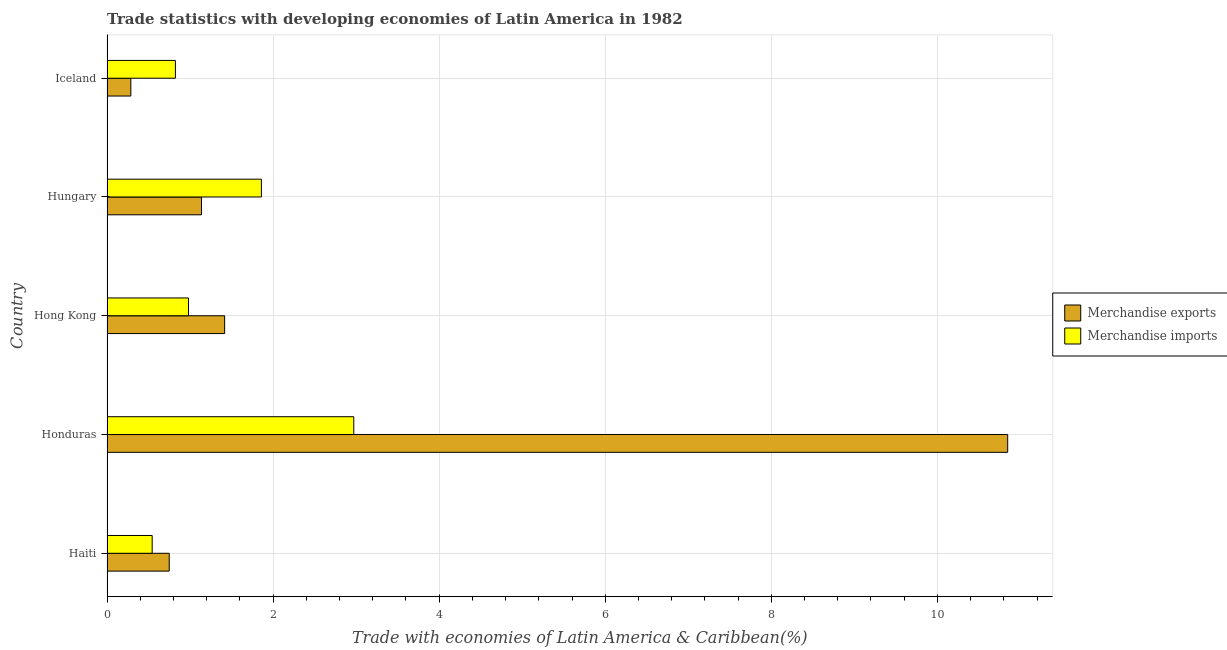How many groups of bars are there?
Ensure brevity in your answer.  5. Are the number of bars on each tick of the Y-axis equal?
Provide a short and direct response. Yes. How many bars are there on the 2nd tick from the top?
Ensure brevity in your answer.  2. How many bars are there on the 4th tick from the bottom?
Provide a succinct answer. 2. What is the label of the 3rd group of bars from the top?
Offer a terse response. Hong Kong. What is the merchandise exports in Hong Kong?
Give a very brief answer. 1.42. Across all countries, what is the maximum merchandise imports?
Your answer should be compact. 2.97. Across all countries, what is the minimum merchandise exports?
Your answer should be compact. 0.29. In which country was the merchandise imports maximum?
Give a very brief answer. Honduras. In which country was the merchandise imports minimum?
Offer a very short reply. Haiti. What is the total merchandise imports in the graph?
Your answer should be compact. 7.18. What is the difference between the merchandise imports in Haiti and that in Honduras?
Offer a terse response. -2.43. What is the difference between the merchandise imports in Hungary and the merchandise exports in Haiti?
Your response must be concise. 1.11. What is the average merchandise exports per country?
Keep it short and to the point. 2.89. What is the difference between the merchandise exports and merchandise imports in Haiti?
Your answer should be very brief. 0.2. In how many countries, is the merchandise imports greater than 0.4 %?
Keep it short and to the point. 5. What is the ratio of the merchandise exports in Hungary to that in Iceland?
Provide a short and direct response. 3.96. What is the difference between the highest and the second highest merchandise imports?
Your response must be concise. 1.11. What is the difference between the highest and the lowest merchandise imports?
Your answer should be very brief. 2.43. Is the sum of the merchandise imports in Hungary and Iceland greater than the maximum merchandise exports across all countries?
Make the answer very short. No. What does the 2nd bar from the top in Iceland represents?
Your answer should be very brief. Merchandise exports. Are all the bars in the graph horizontal?
Your answer should be very brief. Yes. How many countries are there in the graph?
Provide a short and direct response. 5. What is the difference between two consecutive major ticks on the X-axis?
Your answer should be compact. 2. Does the graph contain any zero values?
Offer a terse response. No. Does the graph contain grids?
Ensure brevity in your answer.  Yes. Where does the legend appear in the graph?
Your response must be concise. Center right. How are the legend labels stacked?
Give a very brief answer. Vertical. What is the title of the graph?
Provide a short and direct response. Trade statistics with developing economies of Latin America in 1982. Does "Lowest 20% of population" appear as one of the legend labels in the graph?
Ensure brevity in your answer.  No. What is the label or title of the X-axis?
Give a very brief answer. Trade with economies of Latin America & Caribbean(%). What is the label or title of the Y-axis?
Offer a terse response. Country. What is the Trade with economies of Latin America & Caribbean(%) of Merchandise exports in Haiti?
Provide a short and direct response. 0.75. What is the Trade with economies of Latin America & Caribbean(%) in Merchandise imports in Haiti?
Your response must be concise. 0.54. What is the Trade with economies of Latin America & Caribbean(%) of Merchandise exports in Honduras?
Keep it short and to the point. 10.85. What is the Trade with economies of Latin America & Caribbean(%) of Merchandise imports in Honduras?
Your answer should be compact. 2.97. What is the Trade with economies of Latin America & Caribbean(%) of Merchandise exports in Hong Kong?
Keep it short and to the point. 1.42. What is the Trade with economies of Latin America & Caribbean(%) of Merchandise imports in Hong Kong?
Ensure brevity in your answer.  0.98. What is the Trade with economies of Latin America & Caribbean(%) of Merchandise exports in Hungary?
Give a very brief answer. 1.14. What is the Trade with economies of Latin America & Caribbean(%) in Merchandise imports in Hungary?
Provide a short and direct response. 1.86. What is the Trade with economies of Latin America & Caribbean(%) of Merchandise exports in Iceland?
Offer a very short reply. 0.29. What is the Trade with economies of Latin America & Caribbean(%) of Merchandise imports in Iceland?
Keep it short and to the point. 0.82. Across all countries, what is the maximum Trade with economies of Latin America & Caribbean(%) of Merchandise exports?
Offer a very short reply. 10.85. Across all countries, what is the maximum Trade with economies of Latin America & Caribbean(%) of Merchandise imports?
Your answer should be very brief. 2.97. Across all countries, what is the minimum Trade with economies of Latin America & Caribbean(%) of Merchandise exports?
Keep it short and to the point. 0.29. Across all countries, what is the minimum Trade with economies of Latin America & Caribbean(%) of Merchandise imports?
Ensure brevity in your answer.  0.54. What is the total Trade with economies of Latin America & Caribbean(%) of Merchandise exports in the graph?
Your response must be concise. 14.44. What is the total Trade with economies of Latin America & Caribbean(%) in Merchandise imports in the graph?
Ensure brevity in your answer.  7.18. What is the difference between the Trade with economies of Latin America & Caribbean(%) of Merchandise exports in Haiti and that in Honduras?
Your answer should be compact. -10.1. What is the difference between the Trade with economies of Latin America & Caribbean(%) of Merchandise imports in Haiti and that in Honduras?
Offer a terse response. -2.43. What is the difference between the Trade with economies of Latin America & Caribbean(%) in Merchandise exports in Haiti and that in Hong Kong?
Keep it short and to the point. -0.67. What is the difference between the Trade with economies of Latin America & Caribbean(%) of Merchandise imports in Haiti and that in Hong Kong?
Offer a very short reply. -0.44. What is the difference between the Trade with economies of Latin America & Caribbean(%) of Merchandise exports in Haiti and that in Hungary?
Offer a terse response. -0.39. What is the difference between the Trade with economies of Latin America & Caribbean(%) of Merchandise imports in Haiti and that in Hungary?
Your answer should be very brief. -1.32. What is the difference between the Trade with economies of Latin America & Caribbean(%) of Merchandise exports in Haiti and that in Iceland?
Provide a short and direct response. 0.46. What is the difference between the Trade with economies of Latin America & Caribbean(%) of Merchandise imports in Haiti and that in Iceland?
Your answer should be compact. -0.28. What is the difference between the Trade with economies of Latin America & Caribbean(%) in Merchandise exports in Honduras and that in Hong Kong?
Your answer should be compact. 9.43. What is the difference between the Trade with economies of Latin America & Caribbean(%) in Merchandise imports in Honduras and that in Hong Kong?
Your answer should be compact. 1.99. What is the difference between the Trade with economies of Latin America & Caribbean(%) of Merchandise exports in Honduras and that in Hungary?
Provide a short and direct response. 9.71. What is the difference between the Trade with economies of Latin America & Caribbean(%) of Merchandise imports in Honduras and that in Hungary?
Keep it short and to the point. 1.11. What is the difference between the Trade with economies of Latin America & Caribbean(%) of Merchandise exports in Honduras and that in Iceland?
Ensure brevity in your answer.  10.56. What is the difference between the Trade with economies of Latin America & Caribbean(%) in Merchandise imports in Honduras and that in Iceland?
Offer a terse response. 2.15. What is the difference between the Trade with economies of Latin America & Caribbean(%) in Merchandise exports in Hong Kong and that in Hungary?
Keep it short and to the point. 0.28. What is the difference between the Trade with economies of Latin America & Caribbean(%) of Merchandise imports in Hong Kong and that in Hungary?
Offer a very short reply. -0.88. What is the difference between the Trade with economies of Latin America & Caribbean(%) in Merchandise exports in Hong Kong and that in Iceland?
Your answer should be compact. 1.13. What is the difference between the Trade with economies of Latin America & Caribbean(%) in Merchandise imports in Hong Kong and that in Iceland?
Ensure brevity in your answer.  0.16. What is the difference between the Trade with economies of Latin America & Caribbean(%) in Merchandise exports in Hungary and that in Iceland?
Offer a terse response. 0.85. What is the difference between the Trade with economies of Latin America & Caribbean(%) of Merchandise imports in Hungary and that in Iceland?
Make the answer very short. 1.04. What is the difference between the Trade with economies of Latin America & Caribbean(%) in Merchandise exports in Haiti and the Trade with economies of Latin America & Caribbean(%) in Merchandise imports in Honduras?
Keep it short and to the point. -2.22. What is the difference between the Trade with economies of Latin America & Caribbean(%) in Merchandise exports in Haiti and the Trade with economies of Latin America & Caribbean(%) in Merchandise imports in Hong Kong?
Your answer should be compact. -0.23. What is the difference between the Trade with economies of Latin America & Caribbean(%) of Merchandise exports in Haiti and the Trade with economies of Latin America & Caribbean(%) of Merchandise imports in Hungary?
Keep it short and to the point. -1.11. What is the difference between the Trade with economies of Latin America & Caribbean(%) in Merchandise exports in Haiti and the Trade with economies of Latin America & Caribbean(%) in Merchandise imports in Iceland?
Your response must be concise. -0.07. What is the difference between the Trade with economies of Latin America & Caribbean(%) of Merchandise exports in Honduras and the Trade with economies of Latin America & Caribbean(%) of Merchandise imports in Hong Kong?
Make the answer very short. 9.87. What is the difference between the Trade with economies of Latin America & Caribbean(%) in Merchandise exports in Honduras and the Trade with economies of Latin America & Caribbean(%) in Merchandise imports in Hungary?
Offer a very short reply. 8.99. What is the difference between the Trade with economies of Latin America & Caribbean(%) in Merchandise exports in Honduras and the Trade with economies of Latin America & Caribbean(%) in Merchandise imports in Iceland?
Offer a very short reply. 10.02. What is the difference between the Trade with economies of Latin America & Caribbean(%) of Merchandise exports in Hong Kong and the Trade with economies of Latin America & Caribbean(%) of Merchandise imports in Hungary?
Provide a succinct answer. -0.44. What is the difference between the Trade with economies of Latin America & Caribbean(%) in Merchandise exports in Hong Kong and the Trade with economies of Latin America & Caribbean(%) in Merchandise imports in Iceland?
Offer a terse response. 0.59. What is the difference between the Trade with economies of Latin America & Caribbean(%) in Merchandise exports in Hungary and the Trade with economies of Latin America & Caribbean(%) in Merchandise imports in Iceland?
Keep it short and to the point. 0.31. What is the average Trade with economies of Latin America & Caribbean(%) in Merchandise exports per country?
Give a very brief answer. 2.89. What is the average Trade with economies of Latin America & Caribbean(%) of Merchandise imports per country?
Offer a terse response. 1.44. What is the difference between the Trade with economies of Latin America & Caribbean(%) of Merchandise exports and Trade with economies of Latin America & Caribbean(%) of Merchandise imports in Haiti?
Ensure brevity in your answer.  0.21. What is the difference between the Trade with economies of Latin America & Caribbean(%) in Merchandise exports and Trade with economies of Latin America & Caribbean(%) in Merchandise imports in Honduras?
Make the answer very short. 7.87. What is the difference between the Trade with economies of Latin America & Caribbean(%) in Merchandise exports and Trade with economies of Latin America & Caribbean(%) in Merchandise imports in Hong Kong?
Provide a short and direct response. 0.44. What is the difference between the Trade with economies of Latin America & Caribbean(%) of Merchandise exports and Trade with economies of Latin America & Caribbean(%) of Merchandise imports in Hungary?
Your answer should be very brief. -0.72. What is the difference between the Trade with economies of Latin America & Caribbean(%) in Merchandise exports and Trade with economies of Latin America & Caribbean(%) in Merchandise imports in Iceland?
Your answer should be very brief. -0.54. What is the ratio of the Trade with economies of Latin America & Caribbean(%) of Merchandise exports in Haiti to that in Honduras?
Provide a short and direct response. 0.07. What is the ratio of the Trade with economies of Latin America & Caribbean(%) of Merchandise imports in Haiti to that in Honduras?
Your answer should be very brief. 0.18. What is the ratio of the Trade with economies of Latin America & Caribbean(%) in Merchandise exports in Haiti to that in Hong Kong?
Provide a succinct answer. 0.53. What is the ratio of the Trade with economies of Latin America & Caribbean(%) of Merchandise imports in Haiti to that in Hong Kong?
Keep it short and to the point. 0.55. What is the ratio of the Trade with economies of Latin America & Caribbean(%) in Merchandise exports in Haiti to that in Hungary?
Ensure brevity in your answer.  0.66. What is the ratio of the Trade with economies of Latin America & Caribbean(%) of Merchandise imports in Haiti to that in Hungary?
Provide a succinct answer. 0.29. What is the ratio of the Trade with economies of Latin America & Caribbean(%) in Merchandise exports in Haiti to that in Iceland?
Your response must be concise. 2.61. What is the ratio of the Trade with economies of Latin America & Caribbean(%) in Merchandise imports in Haiti to that in Iceland?
Your answer should be compact. 0.66. What is the ratio of the Trade with economies of Latin America & Caribbean(%) of Merchandise exports in Honduras to that in Hong Kong?
Ensure brevity in your answer.  7.66. What is the ratio of the Trade with economies of Latin America & Caribbean(%) of Merchandise imports in Honduras to that in Hong Kong?
Provide a succinct answer. 3.03. What is the ratio of the Trade with economies of Latin America & Caribbean(%) of Merchandise exports in Honduras to that in Hungary?
Your response must be concise. 9.53. What is the ratio of the Trade with economies of Latin America & Caribbean(%) of Merchandise imports in Honduras to that in Hungary?
Ensure brevity in your answer.  1.6. What is the ratio of the Trade with economies of Latin America & Caribbean(%) in Merchandise exports in Honduras to that in Iceland?
Your answer should be compact. 37.78. What is the ratio of the Trade with economies of Latin America & Caribbean(%) in Merchandise imports in Honduras to that in Iceland?
Your answer should be compact. 3.61. What is the ratio of the Trade with economies of Latin America & Caribbean(%) of Merchandise exports in Hong Kong to that in Hungary?
Provide a succinct answer. 1.25. What is the ratio of the Trade with economies of Latin America & Caribbean(%) of Merchandise imports in Hong Kong to that in Hungary?
Provide a short and direct response. 0.53. What is the ratio of the Trade with economies of Latin America & Caribbean(%) in Merchandise exports in Hong Kong to that in Iceland?
Offer a terse response. 4.93. What is the ratio of the Trade with economies of Latin America & Caribbean(%) in Merchandise imports in Hong Kong to that in Iceland?
Provide a short and direct response. 1.19. What is the ratio of the Trade with economies of Latin America & Caribbean(%) of Merchandise exports in Hungary to that in Iceland?
Provide a succinct answer. 3.96. What is the ratio of the Trade with economies of Latin America & Caribbean(%) in Merchandise imports in Hungary to that in Iceland?
Your answer should be compact. 2.26. What is the difference between the highest and the second highest Trade with economies of Latin America & Caribbean(%) in Merchandise exports?
Ensure brevity in your answer.  9.43. What is the difference between the highest and the second highest Trade with economies of Latin America & Caribbean(%) of Merchandise imports?
Give a very brief answer. 1.11. What is the difference between the highest and the lowest Trade with economies of Latin America & Caribbean(%) in Merchandise exports?
Provide a short and direct response. 10.56. What is the difference between the highest and the lowest Trade with economies of Latin America & Caribbean(%) in Merchandise imports?
Ensure brevity in your answer.  2.43. 